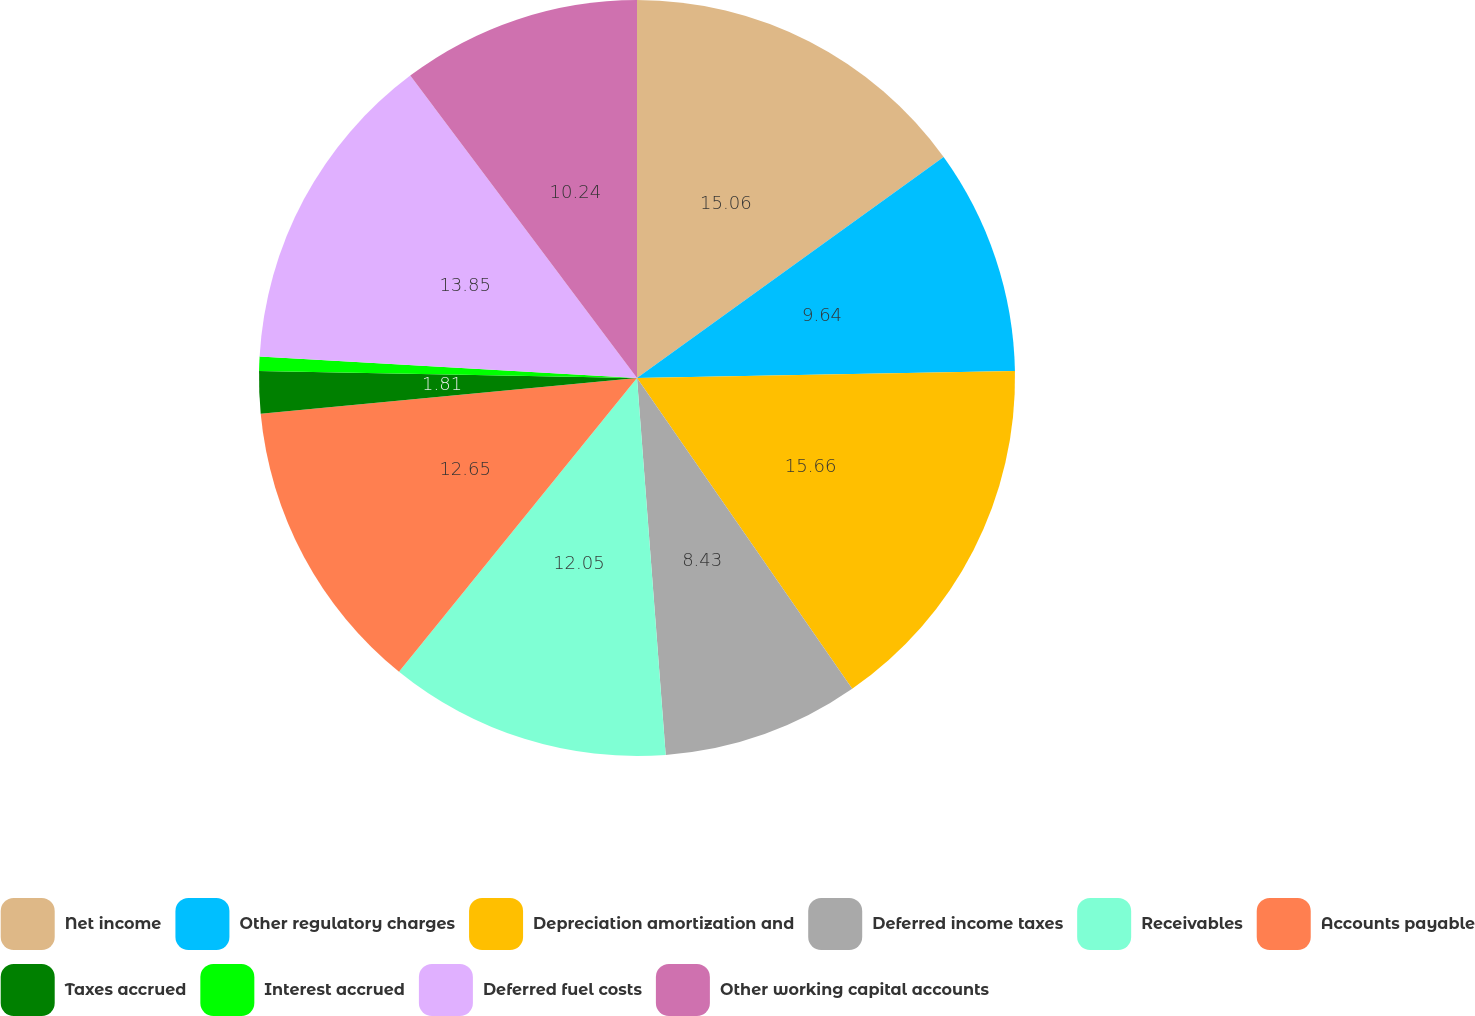Convert chart. <chart><loc_0><loc_0><loc_500><loc_500><pie_chart><fcel>Net income<fcel>Other regulatory charges<fcel>Depreciation amortization and<fcel>Deferred income taxes<fcel>Receivables<fcel>Accounts payable<fcel>Taxes accrued<fcel>Interest accrued<fcel>Deferred fuel costs<fcel>Other working capital accounts<nl><fcel>15.06%<fcel>9.64%<fcel>15.66%<fcel>8.43%<fcel>12.05%<fcel>12.65%<fcel>1.81%<fcel>0.61%<fcel>13.85%<fcel>10.24%<nl></chart> 